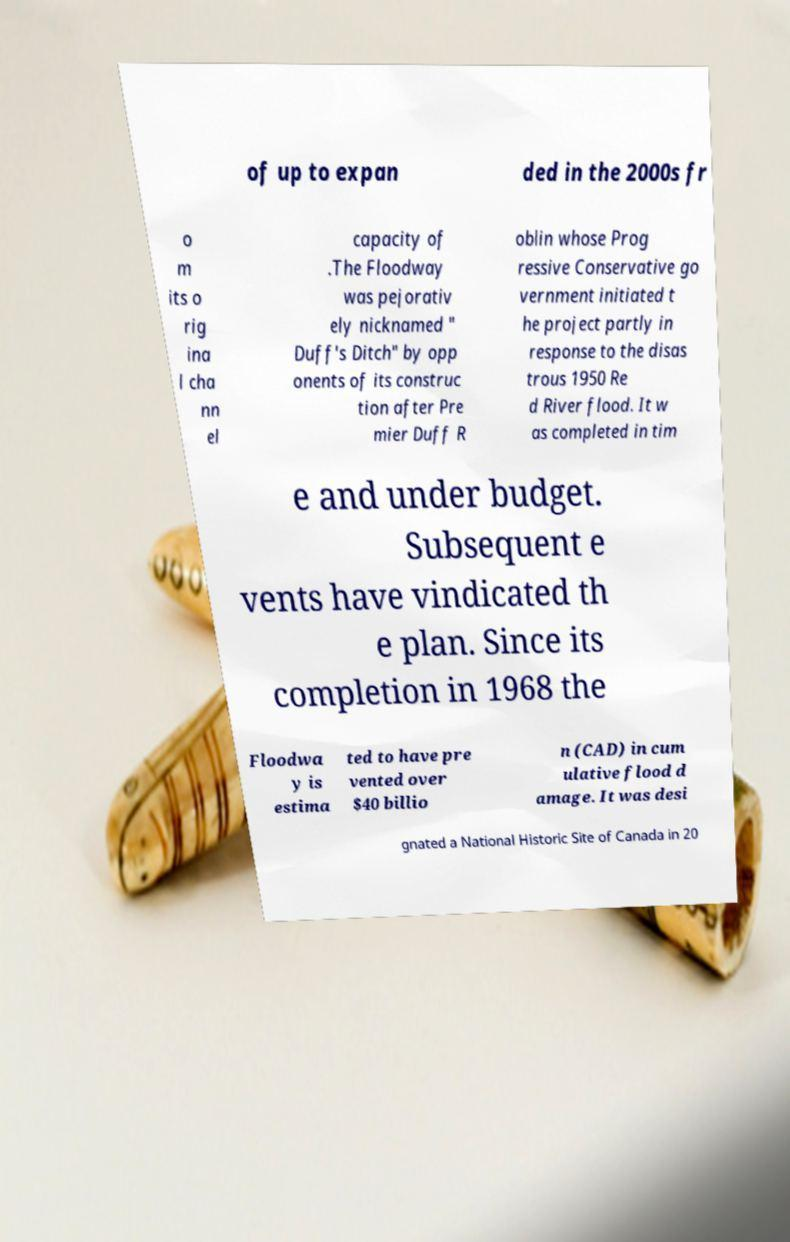Could you extract and type out the text from this image? of up to expan ded in the 2000s fr o m its o rig ina l cha nn el capacity of .The Floodway was pejorativ ely nicknamed " Duff's Ditch" by opp onents of its construc tion after Pre mier Duff R oblin whose Prog ressive Conservative go vernment initiated t he project partly in response to the disas trous 1950 Re d River flood. It w as completed in tim e and under budget. Subsequent e vents have vindicated th e plan. Since its completion in 1968 the Floodwa y is estima ted to have pre vented over $40 billio n (CAD) in cum ulative flood d amage. It was desi gnated a National Historic Site of Canada in 20 